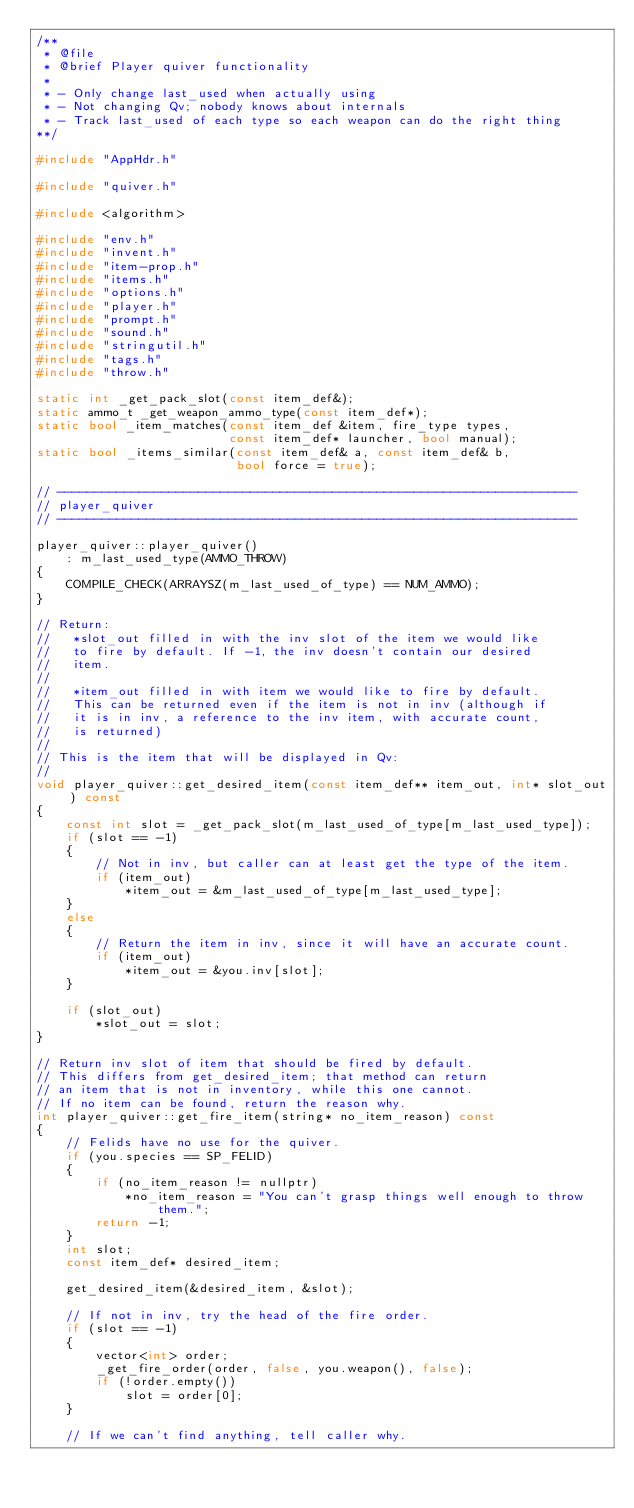<code> <loc_0><loc_0><loc_500><loc_500><_C++_>/**
 * @file
 * @brief Player quiver functionality
 *
 * - Only change last_used when actually using
 * - Not changing Qv; nobody knows about internals
 * - Track last_used of each type so each weapon can do the right thing
**/

#include "AppHdr.h"

#include "quiver.h"

#include <algorithm>

#include "env.h"
#include "invent.h"
#include "item-prop.h"
#include "items.h"
#include "options.h"
#include "player.h"
#include "prompt.h"
#include "sound.h"
#include "stringutil.h"
#include "tags.h"
#include "throw.h"

static int _get_pack_slot(const item_def&);
static ammo_t _get_weapon_ammo_type(const item_def*);
static bool _item_matches(const item_def &item, fire_type types,
                          const item_def* launcher, bool manual);
static bool _items_similar(const item_def& a, const item_def& b,
                           bool force = true);

// ----------------------------------------------------------------------
// player_quiver
// ----------------------------------------------------------------------

player_quiver::player_quiver()
    : m_last_used_type(AMMO_THROW)
{
    COMPILE_CHECK(ARRAYSZ(m_last_used_of_type) == NUM_AMMO);
}

// Return:
//   *slot_out filled in with the inv slot of the item we would like
//   to fire by default. If -1, the inv doesn't contain our desired
//   item.
//
//   *item_out filled in with item we would like to fire by default.
//   This can be returned even if the item is not in inv (although if
//   it is in inv, a reference to the inv item, with accurate count,
//   is returned)
//
// This is the item that will be displayed in Qv:
//
void player_quiver::get_desired_item(const item_def** item_out, int* slot_out) const
{
    const int slot = _get_pack_slot(m_last_used_of_type[m_last_used_type]);
    if (slot == -1)
    {
        // Not in inv, but caller can at least get the type of the item.
        if (item_out)
            *item_out = &m_last_used_of_type[m_last_used_type];
    }
    else
    {
        // Return the item in inv, since it will have an accurate count.
        if (item_out)
            *item_out = &you.inv[slot];
    }

    if (slot_out)
        *slot_out = slot;
}

// Return inv slot of item that should be fired by default.
// This differs from get_desired_item; that method can return
// an item that is not in inventory, while this one cannot.
// If no item can be found, return the reason why.
int player_quiver::get_fire_item(string* no_item_reason) const
{
    // Felids have no use for the quiver.
    if (you.species == SP_FELID)
    {
        if (no_item_reason != nullptr)
            *no_item_reason = "You can't grasp things well enough to throw them.";
        return -1;
    }
    int slot;
    const item_def* desired_item;

    get_desired_item(&desired_item, &slot);

    // If not in inv, try the head of the fire order.
    if (slot == -1)
    {
        vector<int> order;
        _get_fire_order(order, false, you.weapon(), false);
        if (!order.empty())
            slot = order[0];
    }

    // If we can't find anything, tell caller why.</code> 